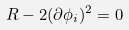<formula> <loc_0><loc_0><loc_500><loc_500>R - 2 ( \partial \phi _ { i } ) ^ { 2 } = 0</formula> 